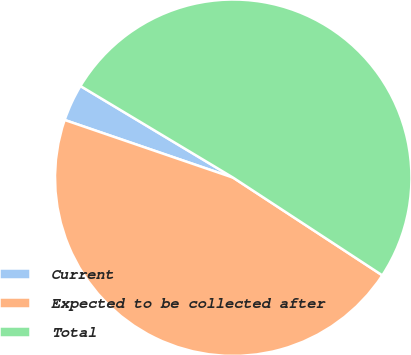Convert chart to OTSL. <chart><loc_0><loc_0><loc_500><loc_500><pie_chart><fcel>Current<fcel>Expected to be collected after<fcel>Total<nl><fcel>3.35%<fcel>46.03%<fcel>50.63%<nl></chart> 